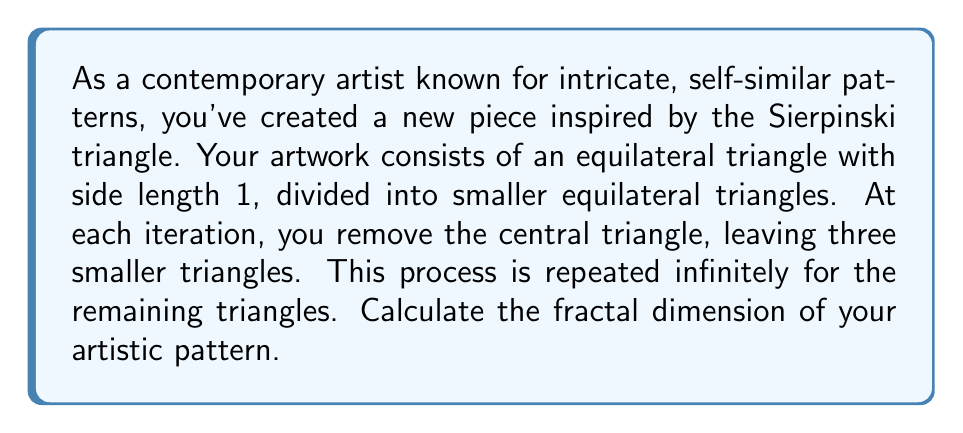Could you help me with this problem? To calculate the fractal dimension of this artistic pattern, we'll use the box-counting method, which is defined by the formula:

$$D = \frac{\log N(r)}{\log(1/r)}$$

Where:
$D$ is the fractal dimension
$N(r)$ is the number of boxes of side length $r$ needed to cover the fractal

For the Sierpinski triangle-inspired pattern:

1. At each iteration, we divide the side length by 2, so $r = (1/2)^n$ where $n$ is the iteration number.

2. The number of triangles (boxes) at each iteration follows the sequence: 3, 9, 27, 81, ..., which can be expressed as $N(r) = 3^n$.

3. Substituting these into our fractal dimension formula:

   $$D = \lim_{n \to \infty} \frac{\log(3^n)}{\log(1/(1/2)^n)} = \lim_{n \to \infty} \frac{n \log(3)}{n \log(2)}$$

4. The $n$ cancels out in the fraction:

   $$D = \frac{\log(3)}{\log(2)}$$

5. Calculating this value:

   $$D = \frac{\log(3)}{\log(2)} \approx 1.5849625007$$

This fractal dimension between 1 and 2 reflects the pattern's complexity, being more than a simple line (dimension 1) but less space-filling than a solid plane (dimension 2).
Answer: The fractal dimension of the artistic pattern is $\frac{\log(3)}{\log(2)} \approx 1.5849625007$. 